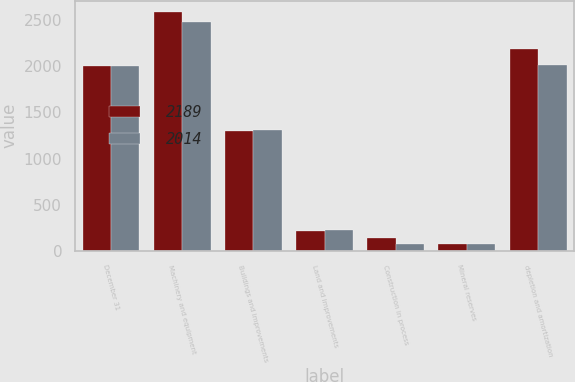<chart> <loc_0><loc_0><loc_500><loc_500><stacked_bar_chart><ecel><fcel>December 31<fcel>Machinery and equipment<fcel>Buildings and improvements<fcel>Land and improvements<fcel>Construction in process<fcel>Mineral reserves<fcel>depletion and amortization<nl><fcel>2189<fcel>2005<fcel>2583<fcel>1303<fcel>216<fcel>137<fcel>75<fcel>2189<nl><fcel>2014<fcel>2004<fcel>2475<fcel>1311<fcel>225<fcel>78<fcel>78<fcel>2014<nl></chart> 